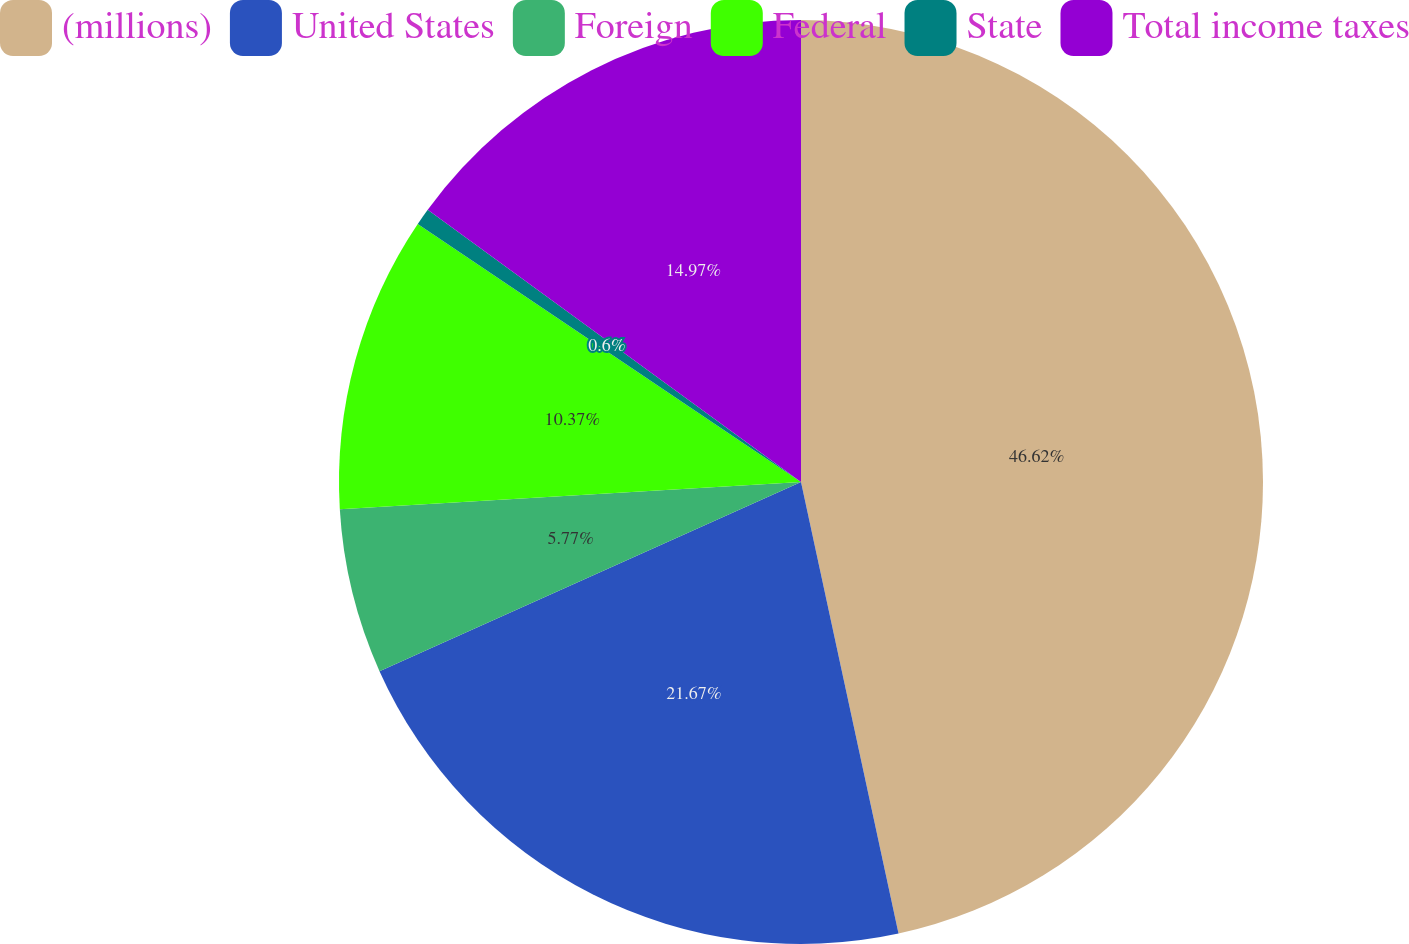Convert chart to OTSL. <chart><loc_0><loc_0><loc_500><loc_500><pie_chart><fcel>(millions)<fcel>United States<fcel>Foreign<fcel>Federal<fcel>State<fcel>Total income taxes<nl><fcel>46.61%<fcel>21.67%<fcel>5.77%<fcel>10.37%<fcel>0.6%<fcel>14.97%<nl></chart> 